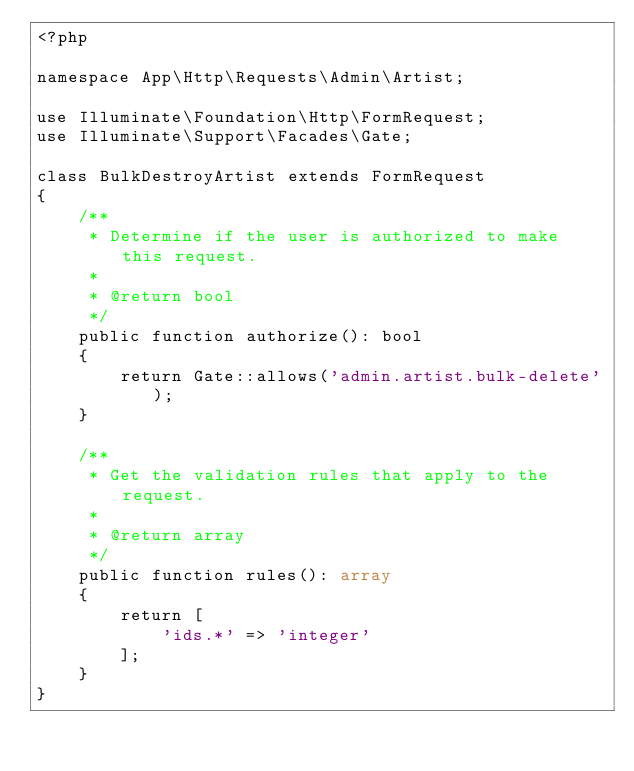Convert code to text. <code><loc_0><loc_0><loc_500><loc_500><_PHP_><?php

namespace App\Http\Requests\Admin\Artist;

use Illuminate\Foundation\Http\FormRequest;
use Illuminate\Support\Facades\Gate;

class BulkDestroyArtist extends FormRequest
{
    /**
     * Determine if the user is authorized to make this request.
     *
     * @return bool
     */
    public function authorize(): bool
    {
        return Gate::allows('admin.artist.bulk-delete');
    }

    /**
     * Get the validation rules that apply to the request.
     *
     * @return array
     */
    public function rules(): array
    {
        return [
            'ids.*' => 'integer'
        ];
    }
}
</code> 